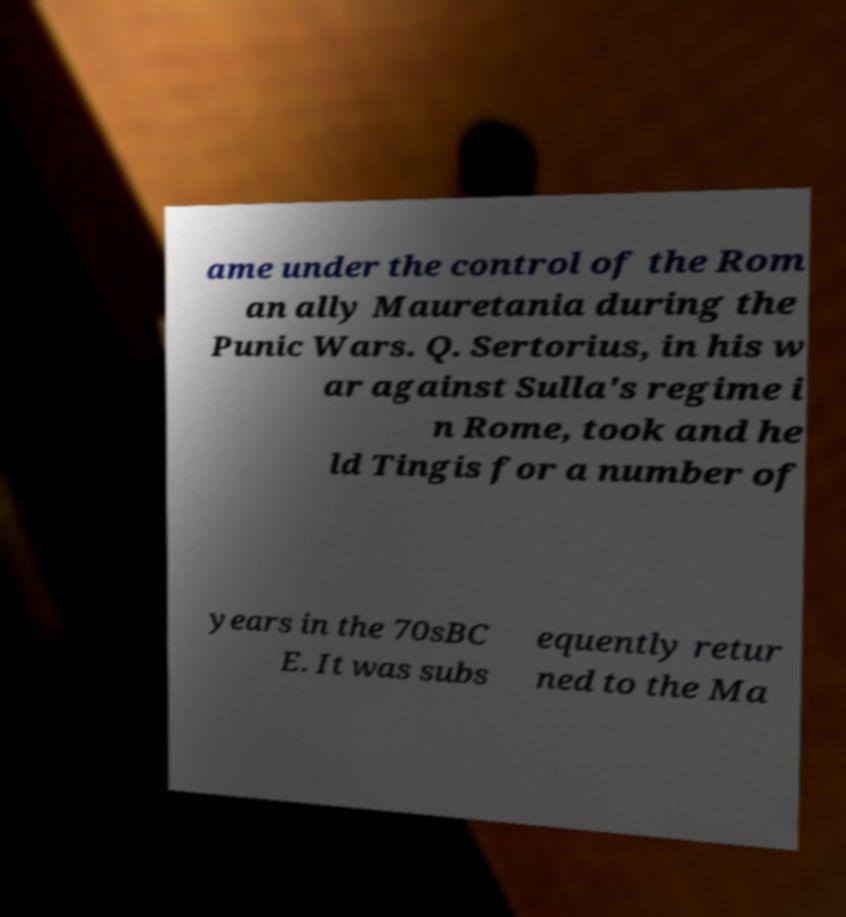Could you assist in decoding the text presented in this image and type it out clearly? ame under the control of the Rom an ally Mauretania during the Punic Wars. Q. Sertorius, in his w ar against Sulla's regime i n Rome, took and he ld Tingis for a number of years in the 70sBC E. It was subs equently retur ned to the Ma 